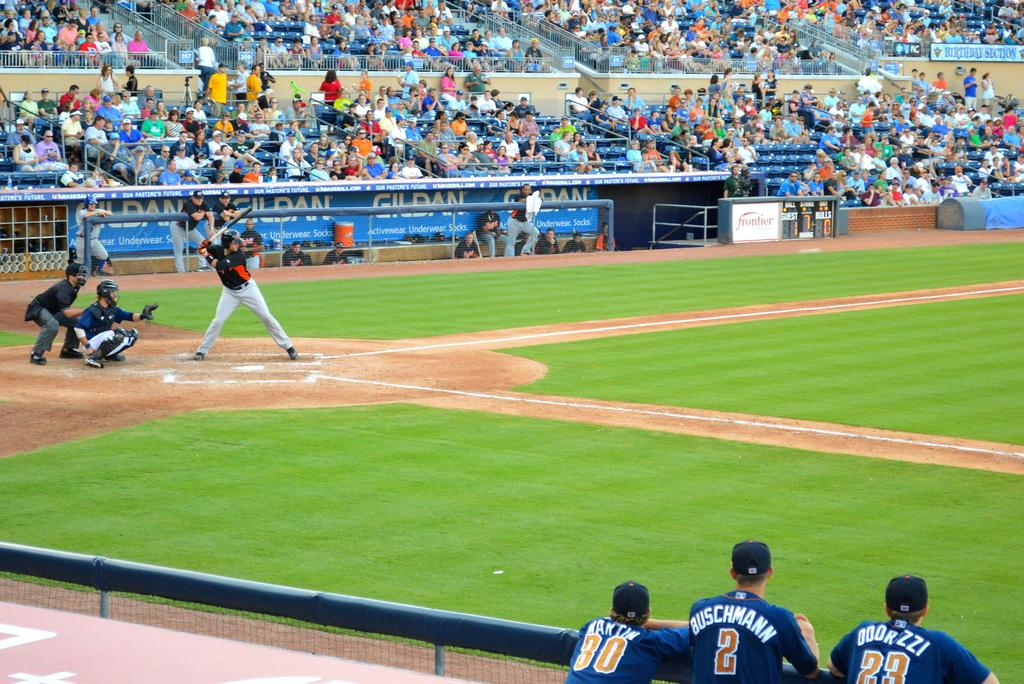<image>
Summarize the visual content of the image. A baseball player in a number two uniform with the last name Buschmann stands at the fence and watches the game with two teammates. 